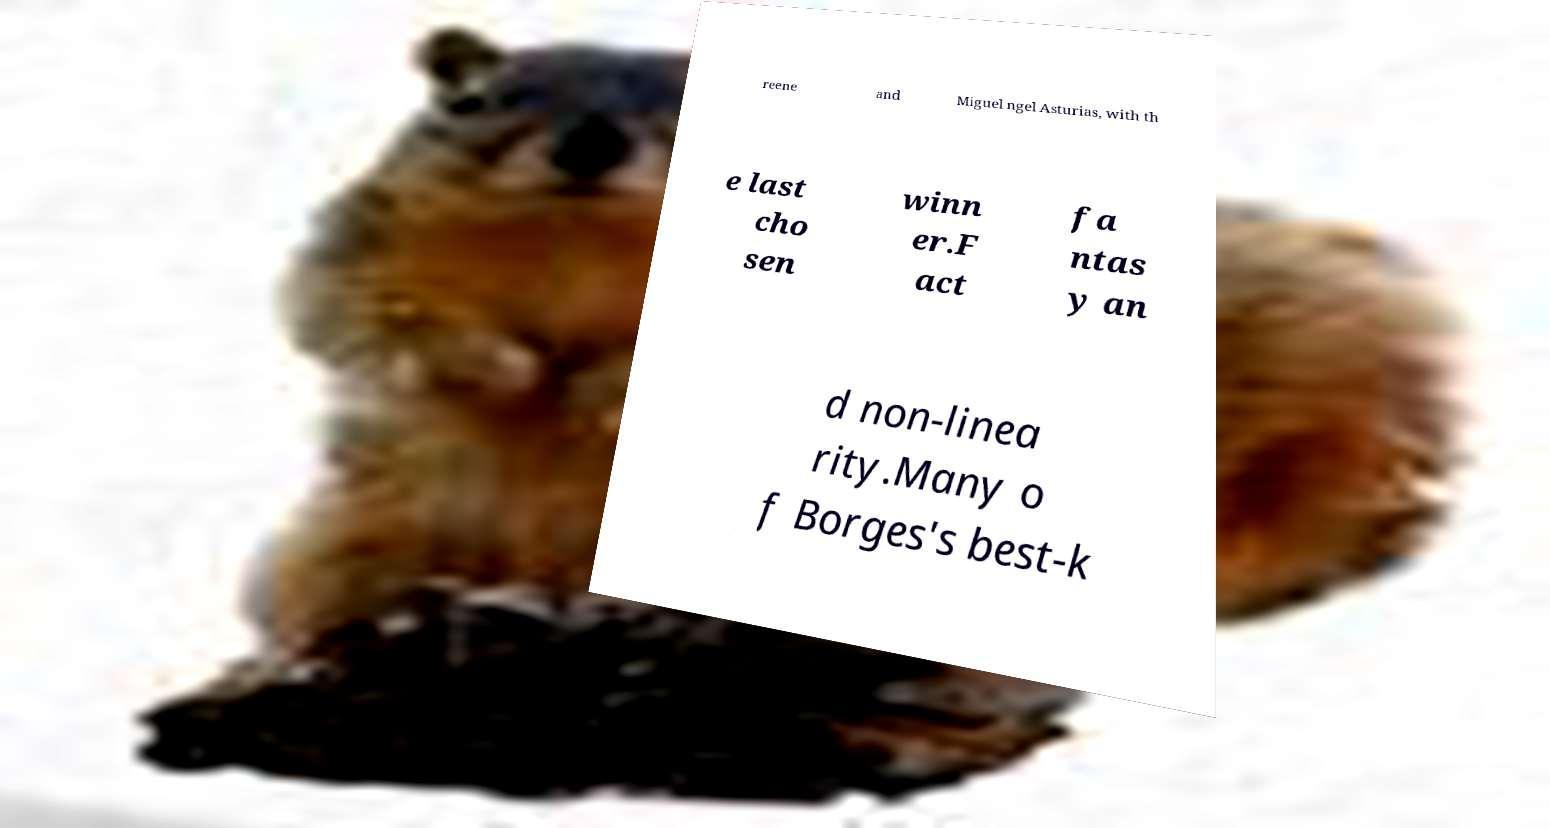Could you assist in decoding the text presented in this image and type it out clearly? reene and Miguel ngel Asturias, with th e last cho sen winn er.F act fa ntas y an d non-linea rity.Many o f Borges's best-k 